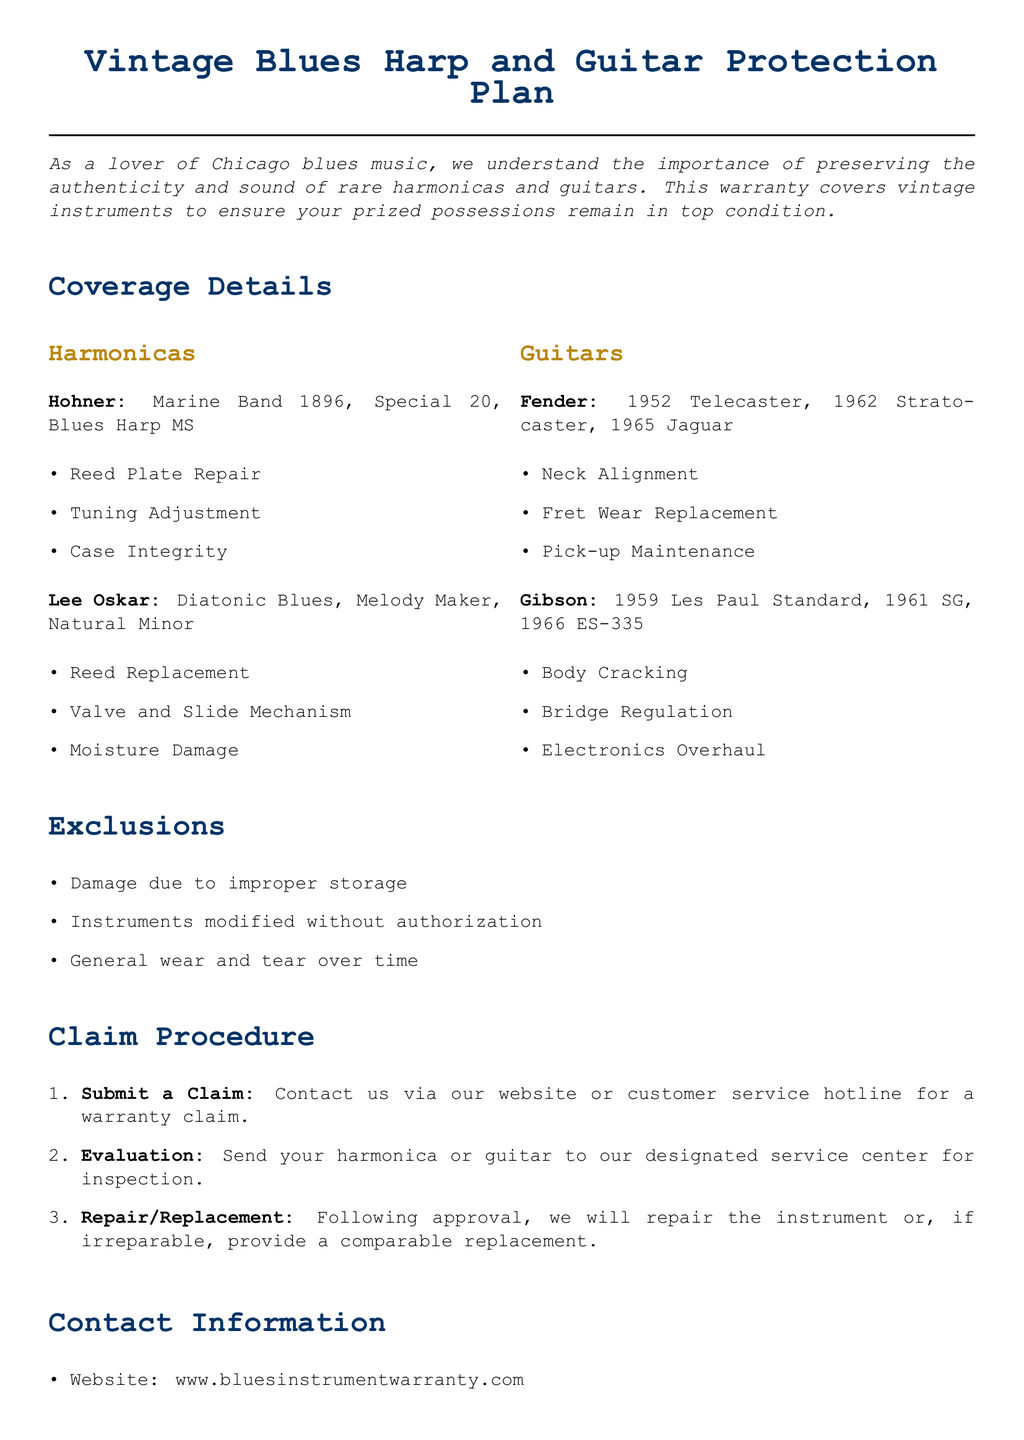What type of instruments are covered? The document lists harmonicas and guitars as the types of instruments covered under the warranty.
Answer: harmonicas and guitars What brands of harmonicas are included? The document specifies Hohner and Lee Oskar as the brands of harmonicas covered.
Answer: Hohner and Lee Oskar What is the warranty exclusion related to modifications? The document states that instruments modified without authorization are excluded from coverage.
Answer: Instruments modified without authorization How many steps are in the claim procedure? The claim procedure consists of three steps as outlined in the document.
Answer: three Which guitar model is listed as a Fender? The document includes the 1962 Stratocaster as one of the Fender guitar models covered.
Answer: 1962 Stratocaster What types of damages does the warranty cover for Hohner harmonicas? The coverage details for Hohner harmonicas include Reed Plate Repair, Tuning Adjustment, and Case Integrity.
Answer: Reed Plate Repair, Tuning Adjustment, Case Integrity What is the first step in the claim procedure? The first step in the claim procedure is to submit a claim.
Answer: Submit a Claim What is the contact phone number for customer service? The document provides a customer service hotline number which is 1-800-BLUES-WAR.
Answer: 1-800-BLUES-WAR 